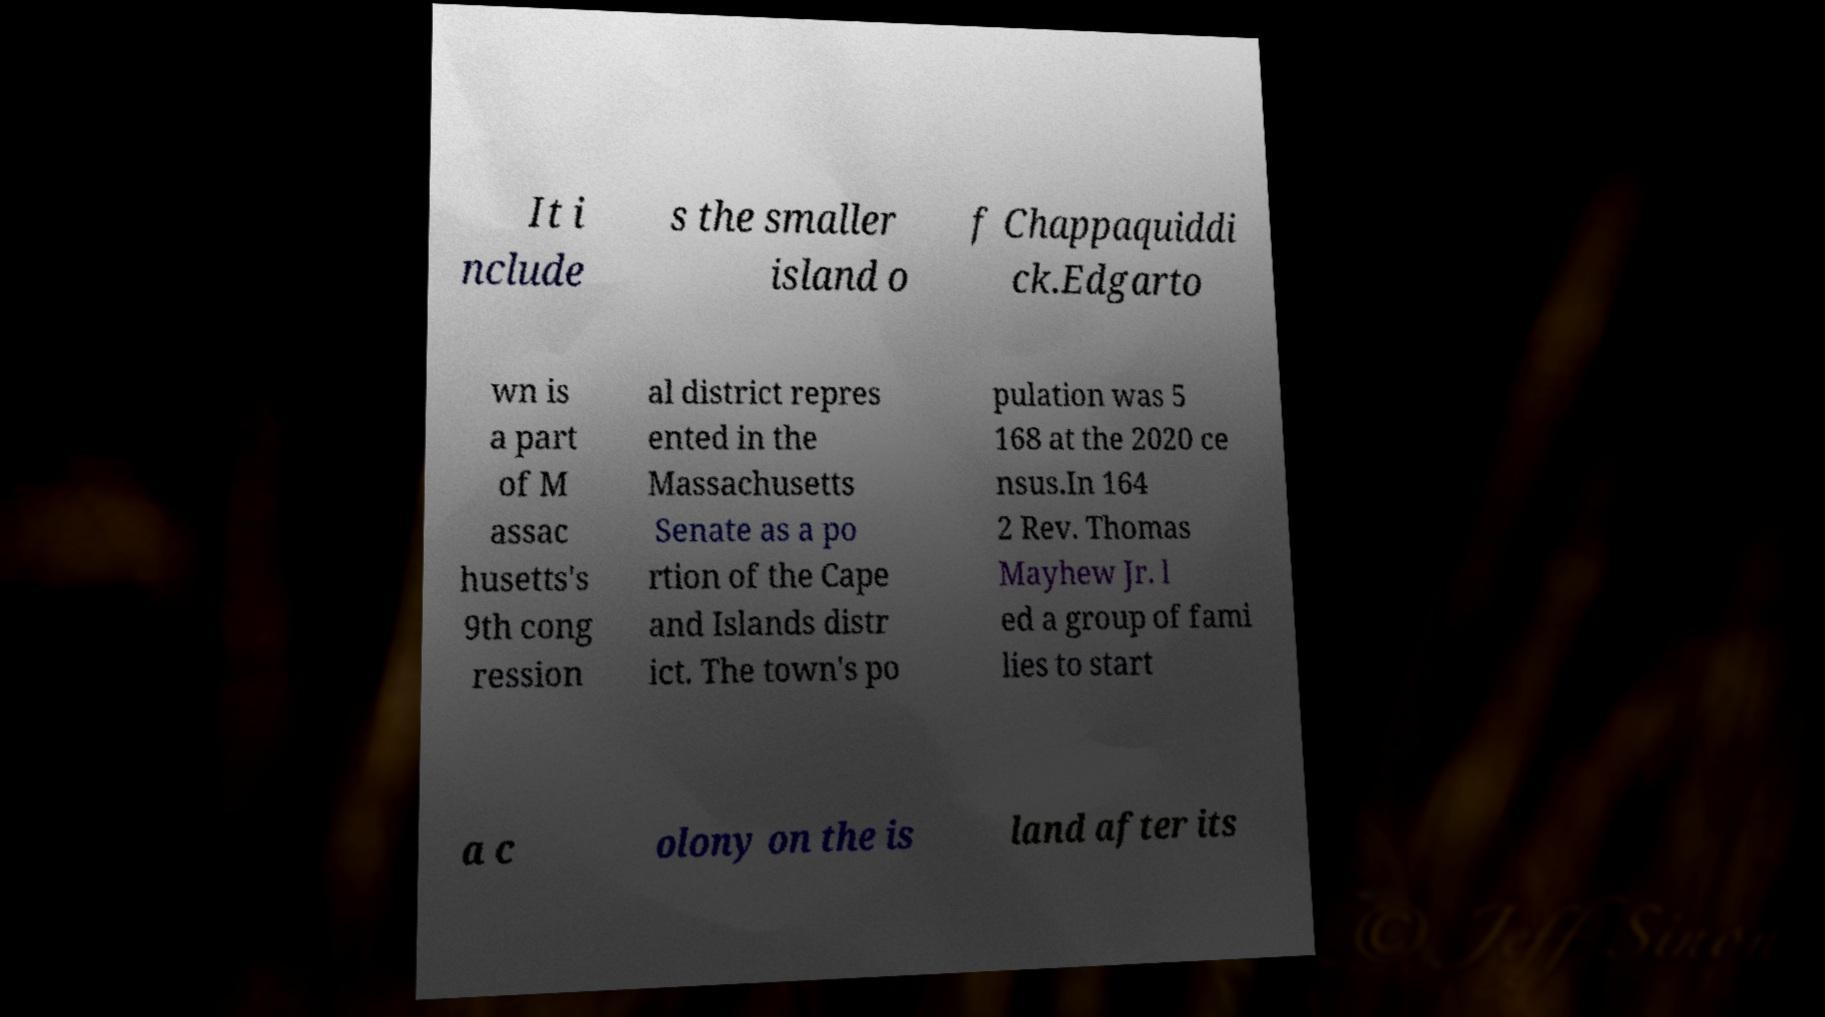Can you accurately transcribe the text from the provided image for me? It i nclude s the smaller island o f Chappaquiddi ck.Edgarto wn is a part of M assac husetts's 9th cong ression al district repres ented in the Massachusetts Senate as a po rtion of the Cape and Islands distr ict. The town's po pulation was 5 168 at the 2020 ce nsus.In 164 2 Rev. Thomas Mayhew Jr. l ed a group of fami lies to start a c olony on the is land after its 